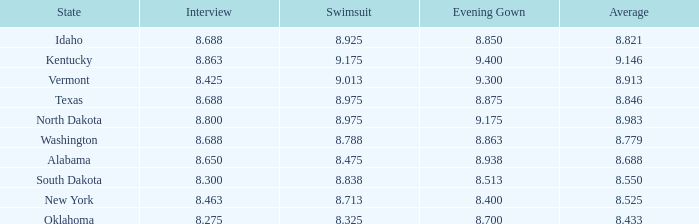What is the highest swimsuit score of the contestant with an evening gown larger than 9.175 and an interview score less than 8.425? None. 